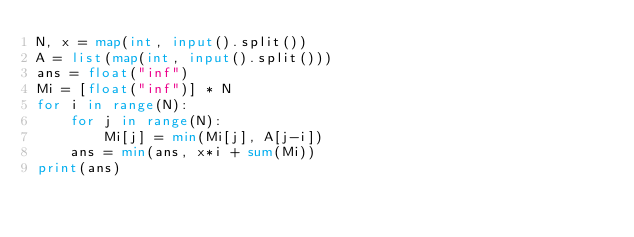Convert code to text. <code><loc_0><loc_0><loc_500><loc_500><_Python_>N, x = map(int, input().split())
A = list(map(int, input().split()))
ans = float("inf")
Mi = [float("inf")] * N
for i in range(N):
    for j in range(N):
        Mi[j] = min(Mi[j], A[j-i])
    ans = min(ans, x*i + sum(Mi))
print(ans)
</code> 